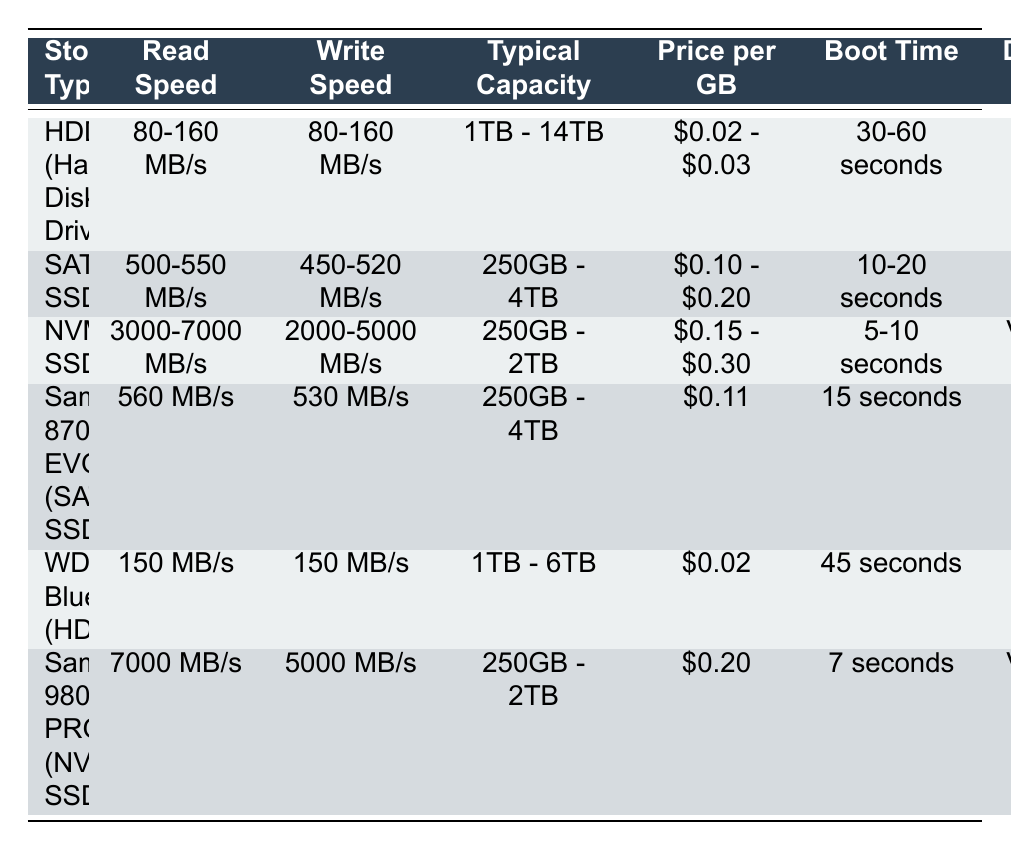What is the read speed of NVMe SSD? The table shows the read speed for NVMe SSD ranges from 3000 to 7000 MB/s.
Answer: 3000-7000 MB/s Which storage type has the fastest write speed? By comparing write speeds in the table, the NVMe SSD, specifically the Samsung 980 PRO, offers the fastest write speed at 5000 MB/s.
Answer: Samsung 980 PRO (NVMe SSD) What is the typical capacity range for HDDs? The HDDs listed in the table, including both types, have a typical capacity range from 1TB to 14TB, as specified in the Typical Capacity column.
Answer: 1TB - 14TB Is the price per GB for SATA SSD higher than that of HDD? The price per GB for SATA SSD ranges from $0.10 to $0.20, while HDD ranges from $0.02 to $0.03. Since $0.10 is greater than $0.03, the statement is true.
Answer: Yes What is the average read speed of SATA SSDs listed in the table? The read speeds for SATA SSDs provided in the table are 500-550 MB/s and 560 MB/s. For the average, convert ranges to averages (525 MB/s and 560 MB/s). Then add them (525 + 560) = 1085 MB/s, and divide by 2. Average read speed = 1085 / 2 = 542.5 MB/s.
Answer: 542.5 MB/s Which storage type offers the longest boot time? By comparing the Boot Time column, both HDDs (30-60 seconds and 45 seconds) have the longest boot time. 60 seconds (max of HDD) is longer than any SSD’s boot times.
Answer: HDD (Hard Disk Drive) Is it true that Samsung 870 EVO has a higher read speed than WD Blue? The read speed for Samsung 870 EVO is 560 MB/s, while WD Blue has a read speed of 150 MB/s. Since 560 is greater than 150, the statement is true.
Answer: Yes What is the difference in price per GB between the cheapest HDD and the most expensive NVMe SSD? The cheapest HDD price per GB is $0.02 and the most expensive NVMe SSD price per GB is $0.30. To find the difference, subtract $0.02 from $0.30, which equals $0.28.
Answer: $0.28 How much faster is the boot time of NVMe SSD compared to SATA SSD on average? The average boot time for NVMe SSD is 7.5 seconds (averaging the range 5-10 seconds) and for SATA SSD is 15 seconds. To find the difference, subtract 7.5 from 15, which equals 7.5 seconds.
Answer: 7.5 seconds 